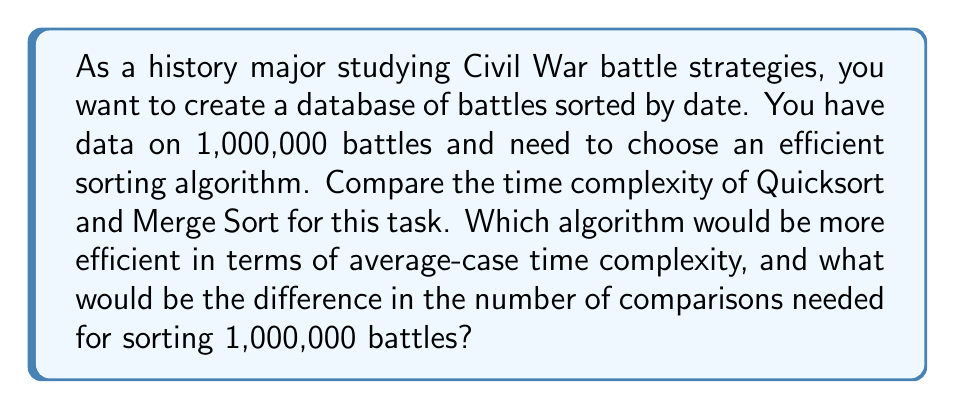Teach me how to tackle this problem. To answer this question, we need to consider the average-case time complexities of Quicksort and Merge Sort:

1. Quicksort:
   Average-case time complexity: $O(n \log n)$
   
2. Merge Sort:
   Average-case time complexity: $O(n \log n)$

Both algorithms have the same average-case time complexity of $O(n \log n)$. However, the constant factors hidden in the big O notation differ:

- Quicksort typically performs $\sim 1.39n \log_2 n$ comparisons on average.
- Merge Sort typically performs $\sim n \log_2 n$ comparisons.

For $n = 1,000,000$ battles:

Quicksort comparisons:
$$ 1.39 \times 1,000,000 \times \log_2(1,000,000) \approx 27,861,858 $$

Merge Sort comparisons:
$$ 1,000,000 \times \log_2(1,000,000) \approx 19,931,568 $$

Difference in comparisons:
$$ 27,861,858 - 19,931,568 = 7,930,290 $$

While both algorithms have the same asymptotic time complexity, Merge Sort would perform fewer comparisons for this dataset size, making it more efficient in practice for sorting the battle data.
Answer: Merge Sort would be more efficient, performing approximately 7,930,290 fewer comparisons than Quicksort for sorting 1,000,000 battles. 